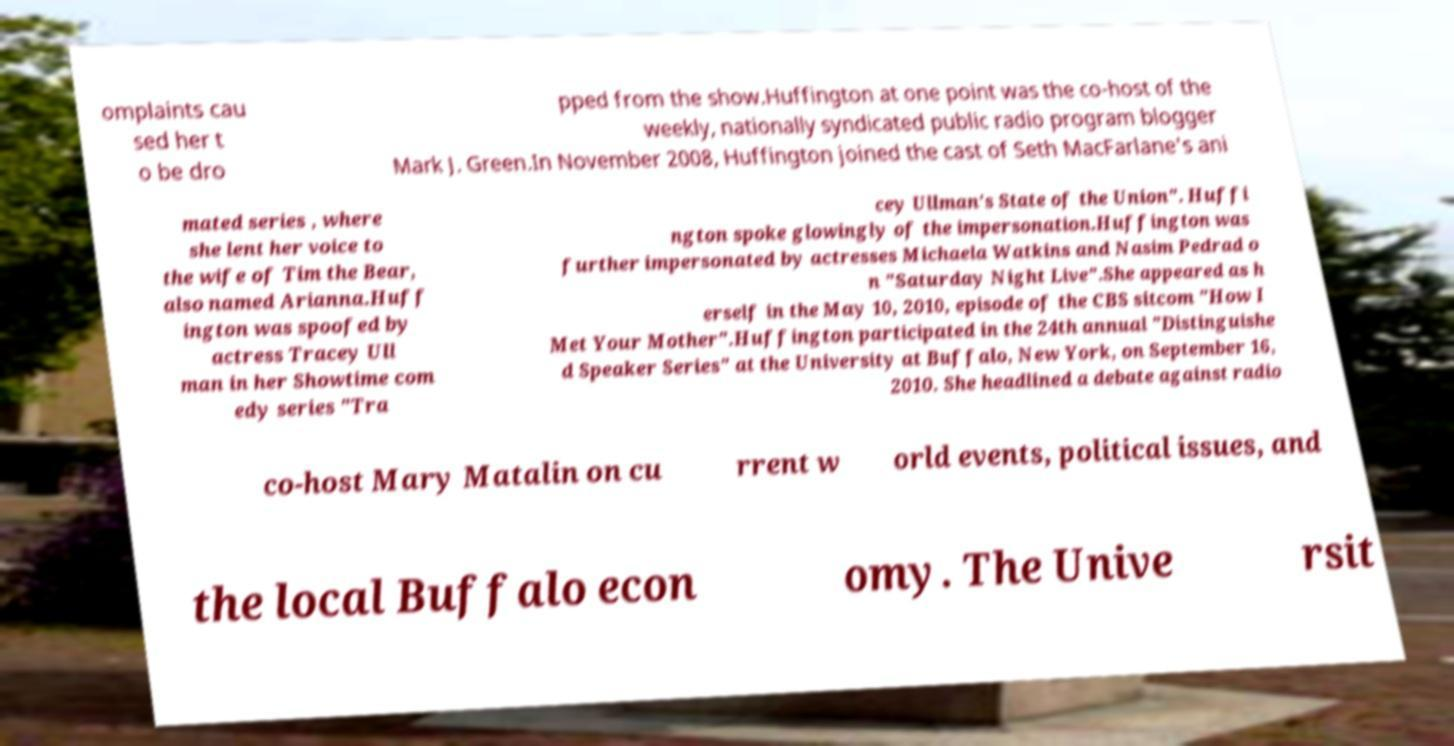I need the written content from this picture converted into text. Can you do that? omplaints cau sed her t o be dro pped from the show.Huffington at one point was the co-host of the weekly, nationally syndicated public radio program blogger Mark J. Green.In November 2008, Huffington joined the cast of Seth MacFarlane's ani mated series , where she lent her voice to the wife of Tim the Bear, also named Arianna.Huff ington was spoofed by actress Tracey Ull man in her Showtime com edy series "Tra cey Ullman's State of the Union". Huffi ngton spoke glowingly of the impersonation.Huffington was further impersonated by actresses Michaela Watkins and Nasim Pedrad o n "Saturday Night Live".She appeared as h erself in the May 10, 2010, episode of the CBS sitcom "How I Met Your Mother".Huffington participated in the 24th annual "Distinguishe d Speaker Series" at the University at Buffalo, New York, on September 16, 2010. She headlined a debate against radio co-host Mary Matalin on cu rrent w orld events, political issues, and the local Buffalo econ omy. The Unive rsit 